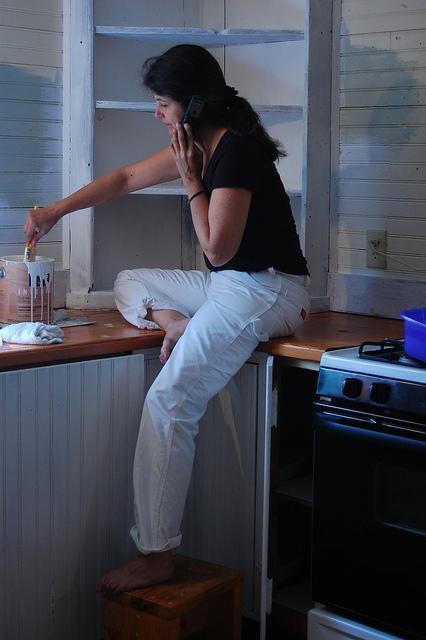Is the caption "The person is facing away from the oven." a true representation of the image?
Answer yes or no. Yes. 